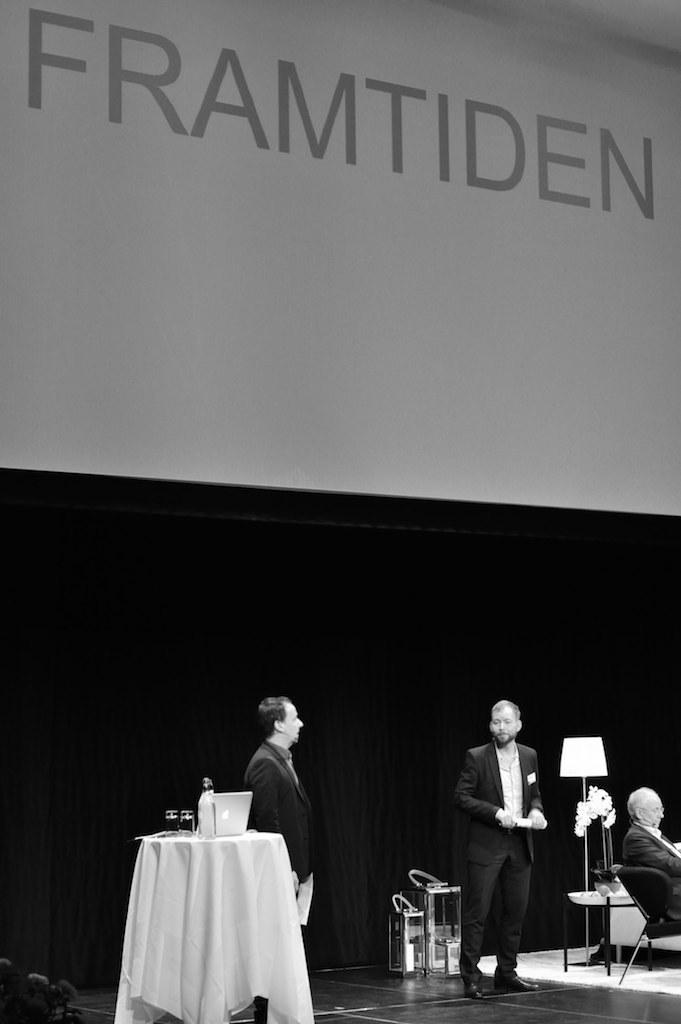How many people are present in the image? There are two persons standing in the image, and one person sitting on a chair. What is the person sitting on a chair doing? The person sitting on a chair is likely using the laptop on the table. What can be seen in the background of the image? There is a poster visible in the background. What type of crime is being committed in the image? There is no indication of any crime being committed in the image. The image shows three people in a room with a laptop and a poster in the background. 